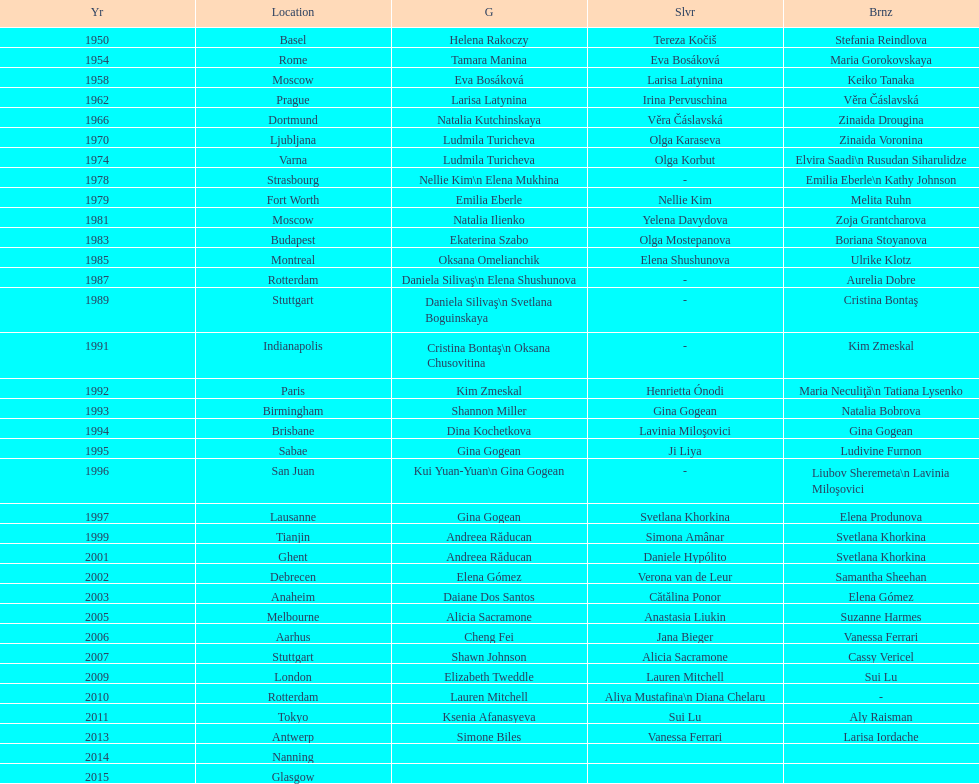How long is the time between the times the championship was held in moscow? 23 years. 